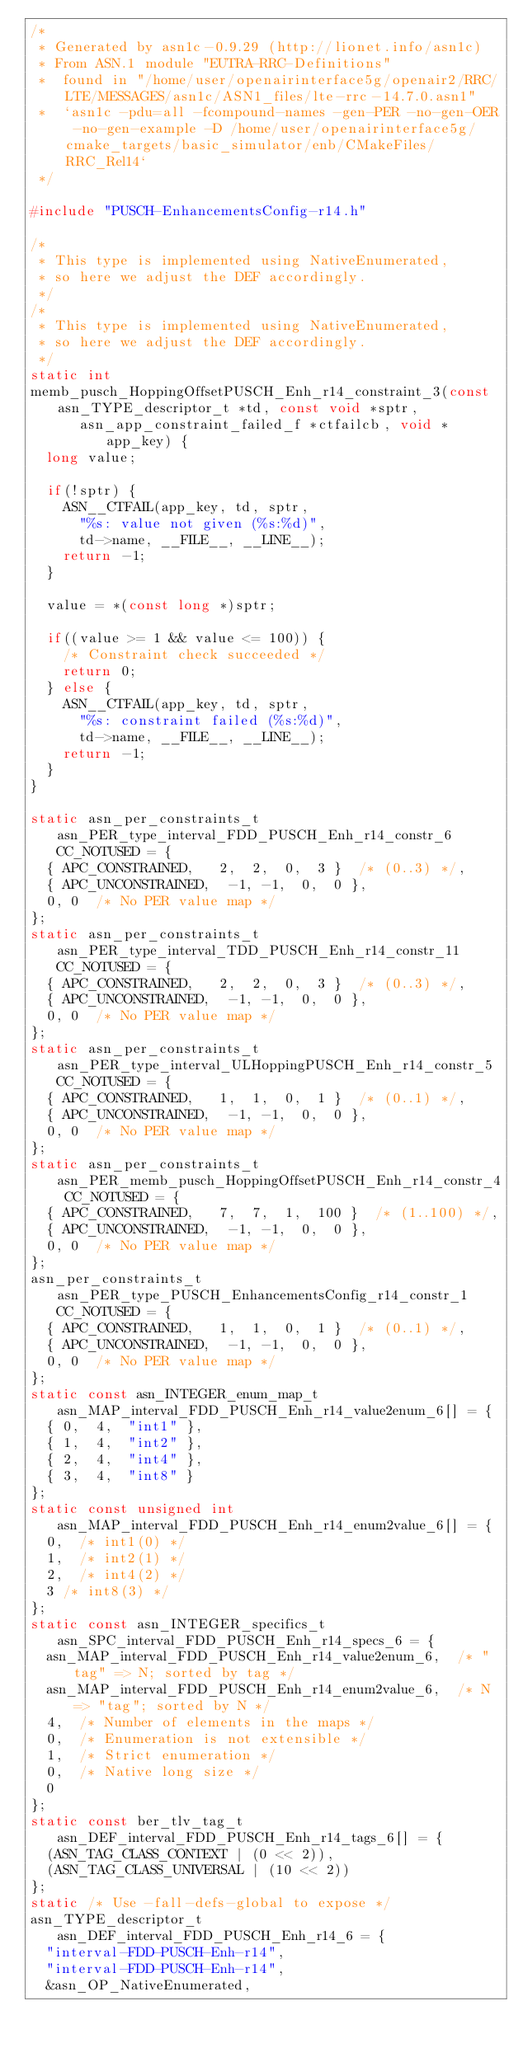<code> <loc_0><loc_0><loc_500><loc_500><_C_>/*
 * Generated by asn1c-0.9.29 (http://lionet.info/asn1c)
 * From ASN.1 module "EUTRA-RRC-Definitions"
 * 	found in "/home/user/openairinterface5g/openair2/RRC/LTE/MESSAGES/asn1c/ASN1_files/lte-rrc-14.7.0.asn1"
 * 	`asn1c -pdu=all -fcompound-names -gen-PER -no-gen-OER -no-gen-example -D /home/user/openairinterface5g/cmake_targets/basic_simulator/enb/CMakeFiles/RRC_Rel14`
 */

#include "PUSCH-EnhancementsConfig-r14.h"

/*
 * This type is implemented using NativeEnumerated,
 * so here we adjust the DEF accordingly.
 */
/*
 * This type is implemented using NativeEnumerated,
 * so here we adjust the DEF accordingly.
 */
static int
memb_pusch_HoppingOffsetPUSCH_Enh_r14_constraint_3(const asn_TYPE_descriptor_t *td, const void *sptr,
			asn_app_constraint_failed_f *ctfailcb, void *app_key) {
	long value;
	
	if(!sptr) {
		ASN__CTFAIL(app_key, td, sptr,
			"%s: value not given (%s:%d)",
			td->name, __FILE__, __LINE__);
		return -1;
	}
	
	value = *(const long *)sptr;
	
	if((value >= 1 && value <= 100)) {
		/* Constraint check succeeded */
		return 0;
	} else {
		ASN__CTFAIL(app_key, td, sptr,
			"%s: constraint failed (%s:%d)",
			td->name, __FILE__, __LINE__);
		return -1;
	}
}

static asn_per_constraints_t asn_PER_type_interval_FDD_PUSCH_Enh_r14_constr_6 CC_NOTUSED = {
	{ APC_CONSTRAINED,	 2,  2,  0,  3 }	/* (0..3) */,
	{ APC_UNCONSTRAINED,	-1, -1,  0,  0 },
	0, 0	/* No PER value map */
};
static asn_per_constraints_t asn_PER_type_interval_TDD_PUSCH_Enh_r14_constr_11 CC_NOTUSED = {
	{ APC_CONSTRAINED,	 2,  2,  0,  3 }	/* (0..3) */,
	{ APC_UNCONSTRAINED,	-1, -1,  0,  0 },
	0, 0	/* No PER value map */
};
static asn_per_constraints_t asn_PER_type_interval_ULHoppingPUSCH_Enh_r14_constr_5 CC_NOTUSED = {
	{ APC_CONSTRAINED,	 1,  1,  0,  1 }	/* (0..1) */,
	{ APC_UNCONSTRAINED,	-1, -1,  0,  0 },
	0, 0	/* No PER value map */
};
static asn_per_constraints_t asn_PER_memb_pusch_HoppingOffsetPUSCH_Enh_r14_constr_4 CC_NOTUSED = {
	{ APC_CONSTRAINED,	 7,  7,  1,  100 }	/* (1..100) */,
	{ APC_UNCONSTRAINED,	-1, -1,  0,  0 },
	0, 0	/* No PER value map */
};
asn_per_constraints_t asn_PER_type_PUSCH_EnhancementsConfig_r14_constr_1 CC_NOTUSED = {
	{ APC_CONSTRAINED,	 1,  1,  0,  1 }	/* (0..1) */,
	{ APC_UNCONSTRAINED,	-1, -1,  0,  0 },
	0, 0	/* No PER value map */
};
static const asn_INTEGER_enum_map_t asn_MAP_interval_FDD_PUSCH_Enh_r14_value2enum_6[] = {
	{ 0,	4,	"int1" },
	{ 1,	4,	"int2" },
	{ 2,	4,	"int4" },
	{ 3,	4,	"int8" }
};
static const unsigned int asn_MAP_interval_FDD_PUSCH_Enh_r14_enum2value_6[] = {
	0,	/* int1(0) */
	1,	/* int2(1) */
	2,	/* int4(2) */
	3	/* int8(3) */
};
static const asn_INTEGER_specifics_t asn_SPC_interval_FDD_PUSCH_Enh_r14_specs_6 = {
	asn_MAP_interval_FDD_PUSCH_Enh_r14_value2enum_6,	/* "tag" => N; sorted by tag */
	asn_MAP_interval_FDD_PUSCH_Enh_r14_enum2value_6,	/* N => "tag"; sorted by N */
	4,	/* Number of elements in the maps */
	0,	/* Enumeration is not extensible */
	1,	/* Strict enumeration */
	0,	/* Native long size */
	0
};
static const ber_tlv_tag_t asn_DEF_interval_FDD_PUSCH_Enh_r14_tags_6[] = {
	(ASN_TAG_CLASS_CONTEXT | (0 << 2)),
	(ASN_TAG_CLASS_UNIVERSAL | (10 << 2))
};
static /* Use -fall-defs-global to expose */
asn_TYPE_descriptor_t asn_DEF_interval_FDD_PUSCH_Enh_r14_6 = {
	"interval-FDD-PUSCH-Enh-r14",
	"interval-FDD-PUSCH-Enh-r14",
	&asn_OP_NativeEnumerated,</code> 